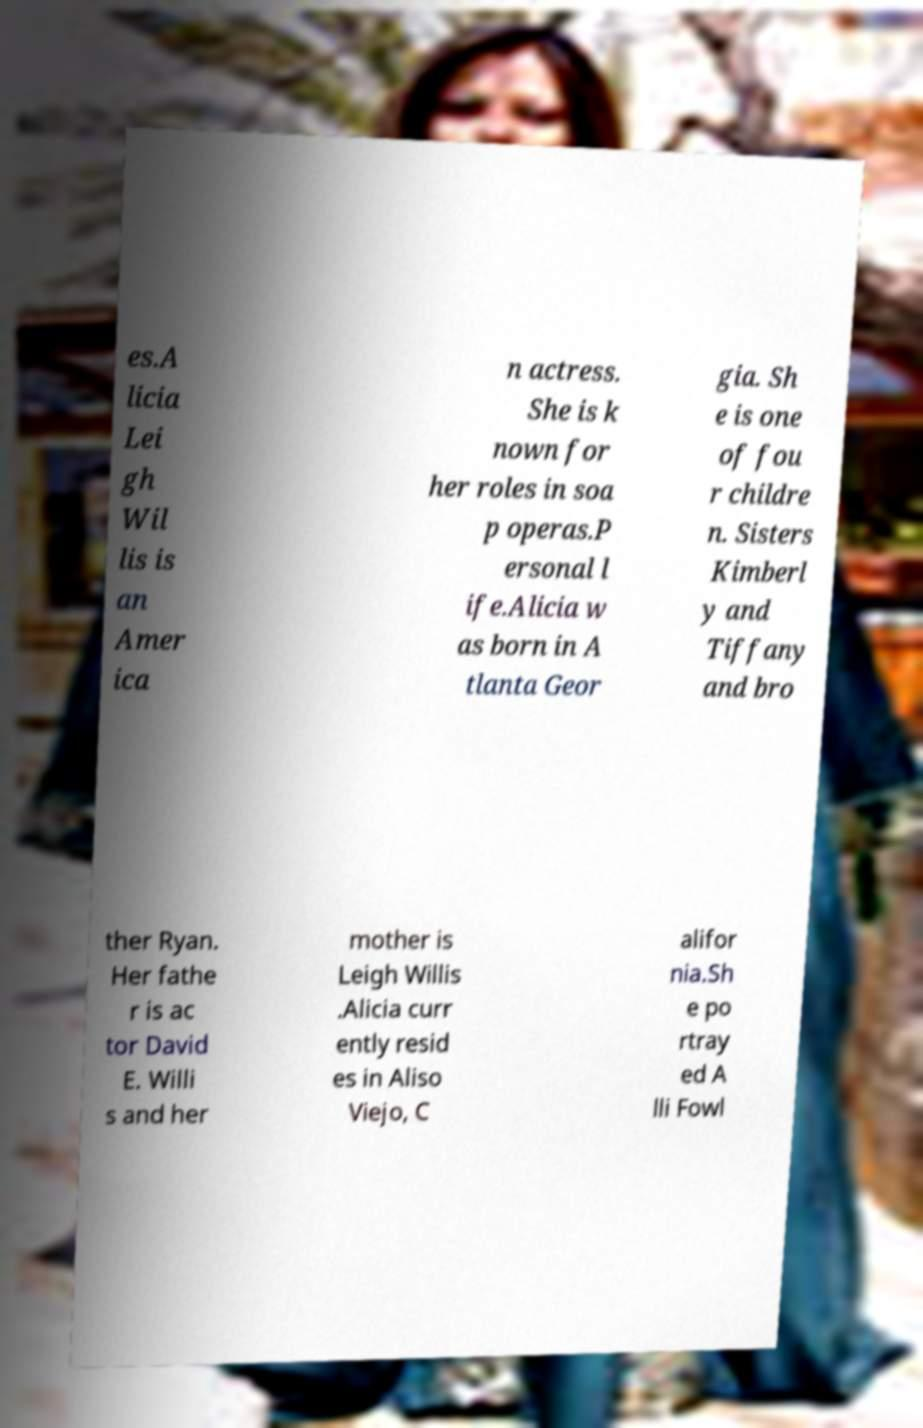Please identify and transcribe the text found in this image. es.A licia Lei gh Wil lis is an Amer ica n actress. She is k nown for her roles in soa p operas.P ersonal l ife.Alicia w as born in A tlanta Geor gia. Sh e is one of fou r childre n. Sisters Kimberl y and Tiffany and bro ther Ryan. Her fathe r is ac tor David E. Willi s and her mother is Leigh Willis .Alicia curr ently resid es in Aliso Viejo, C alifor nia.Sh e po rtray ed A lli Fowl 